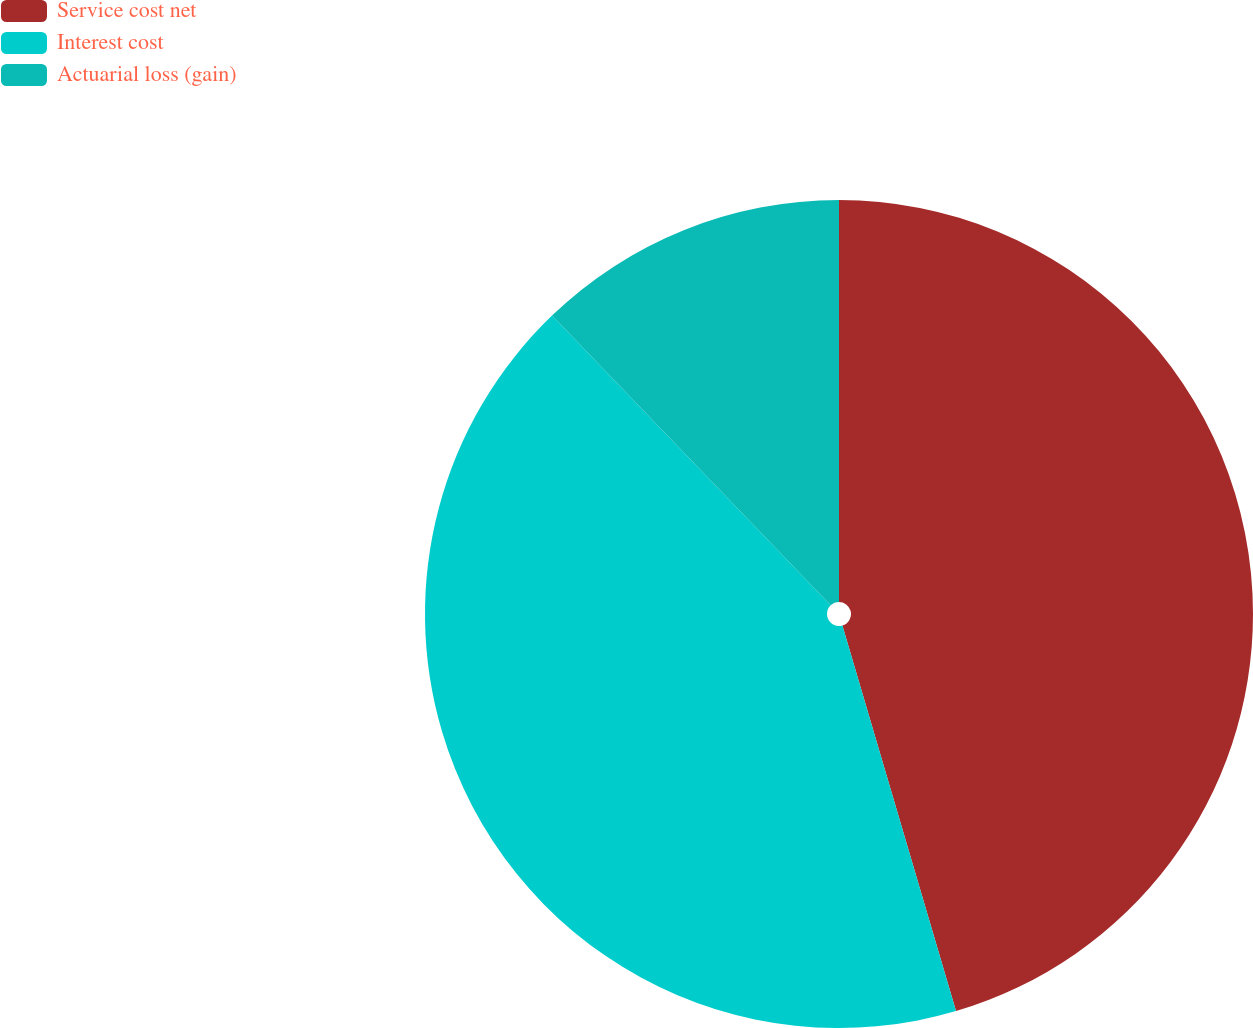<chart> <loc_0><loc_0><loc_500><loc_500><pie_chart><fcel>Service cost net<fcel>Interest cost<fcel>Actuarial loss (gain)<nl><fcel>45.44%<fcel>42.37%<fcel>12.19%<nl></chart> 